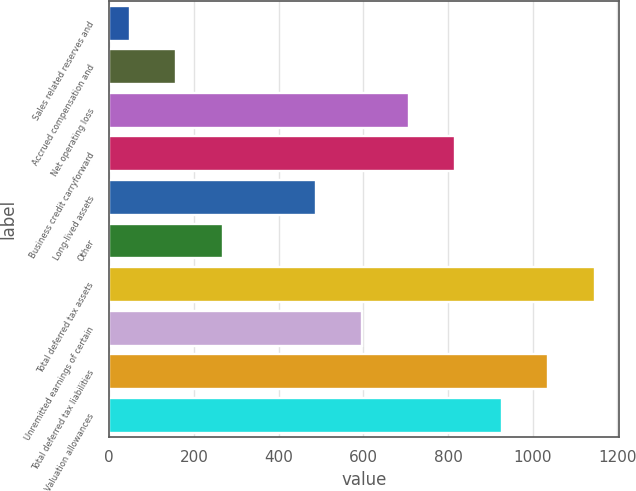Convert chart. <chart><loc_0><loc_0><loc_500><loc_500><bar_chart><fcel>Sales related reserves and<fcel>Accrued compensation and<fcel>Net operating loss<fcel>Business credit carryforward<fcel>Long-lived assets<fcel>Other<fcel>Total deferred tax assets<fcel>Unremitted earnings of certain<fcel>Total deferred tax liabilities<fcel>Valuation allowances<nl><fcel>48<fcel>157.8<fcel>706.8<fcel>816.6<fcel>487.2<fcel>267.6<fcel>1146<fcel>597<fcel>1036.2<fcel>926.4<nl></chart> 